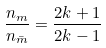Convert formula to latex. <formula><loc_0><loc_0><loc_500><loc_500>\frac { n _ { m } } { n _ { \bar { m } } } = \frac { 2 k + 1 } { 2 k - 1 }</formula> 